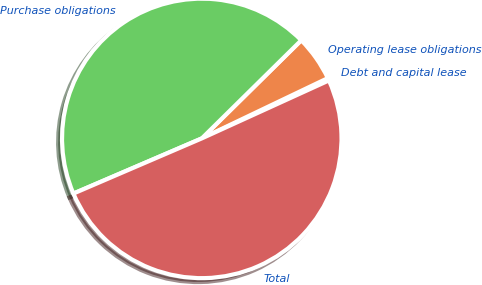Convert chart. <chart><loc_0><loc_0><loc_500><loc_500><pie_chart><fcel>Debt and capital lease<fcel>Operating lease obligations<fcel>Purchase obligations<fcel>Total<nl><fcel>0.29%<fcel>5.29%<fcel>44.07%<fcel>50.35%<nl></chart> 